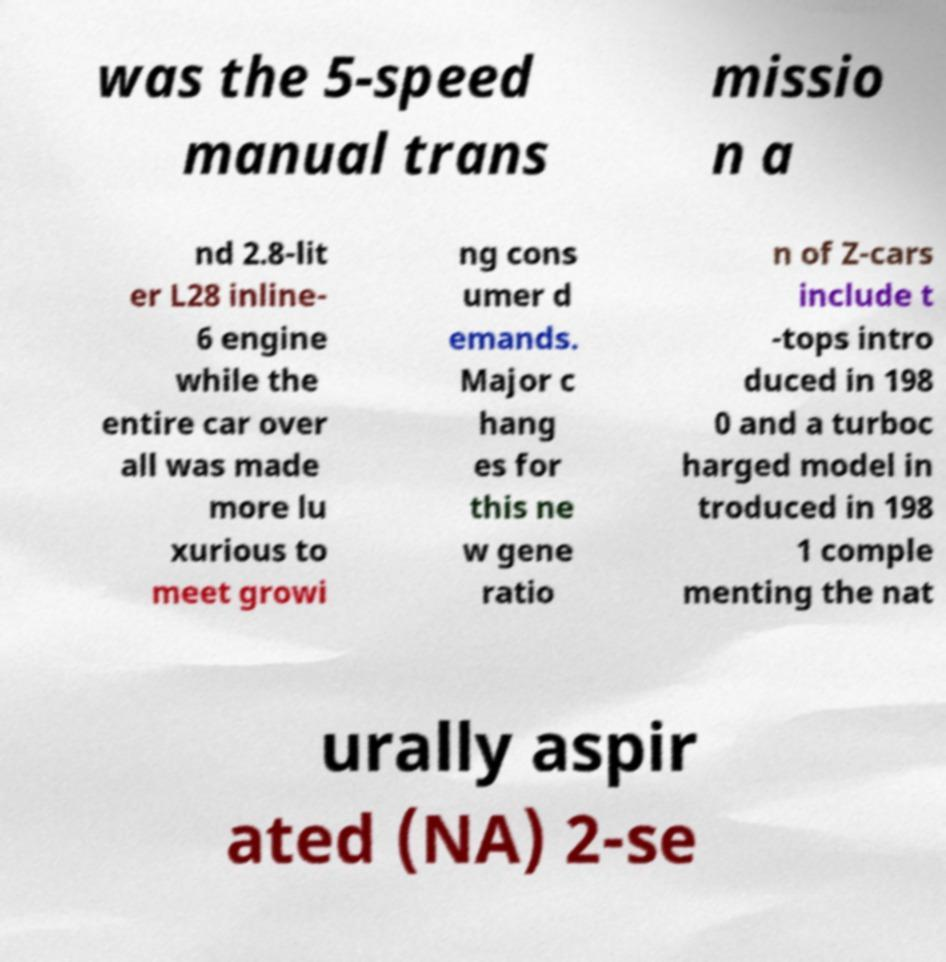For documentation purposes, I need the text within this image transcribed. Could you provide that? was the 5-speed manual trans missio n a nd 2.8-lit er L28 inline- 6 engine while the entire car over all was made more lu xurious to meet growi ng cons umer d emands. Major c hang es for this ne w gene ratio n of Z-cars include t -tops intro duced in 198 0 and a turboc harged model in troduced in 198 1 comple menting the nat urally aspir ated (NA) 2-se 